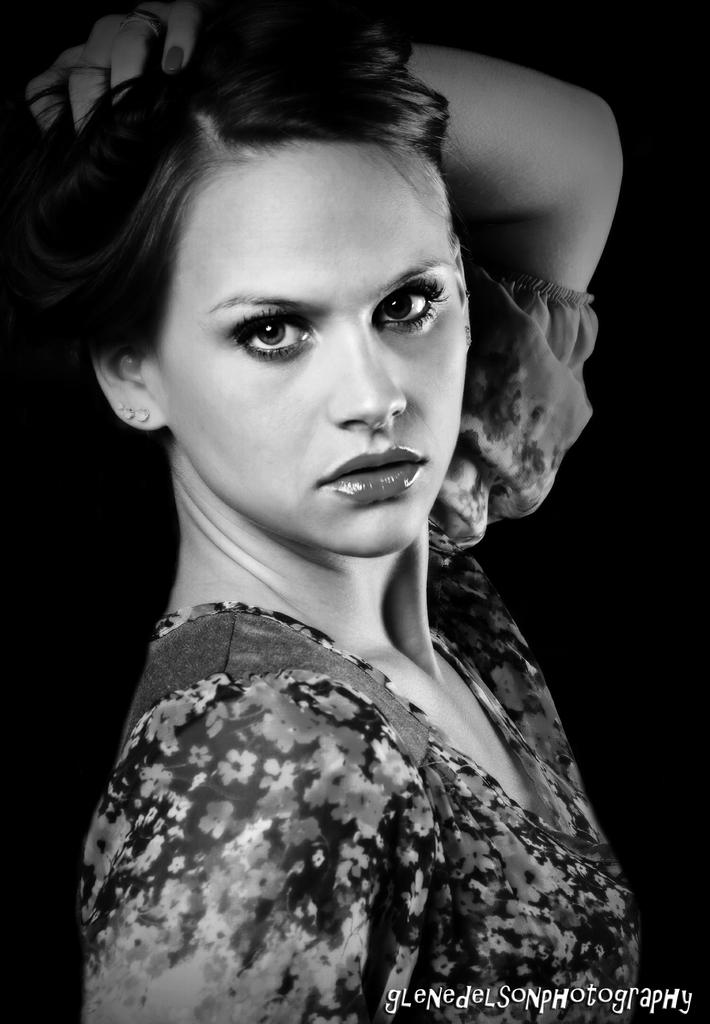What is the color scheme of the image? The image is black and white. Who is present in the image? There is a woman in the image. What is the woman doing in the image? The woman is posing to the camera. What can be seen in the background of the image? The background of the image is dark. Can you see any basketball players stuck in quicksand in the image? There are no basketball players or quicksand present in the image; it features a woman posing in a dark background. What type of vegetable is being used as a prop in the image? There is no vegetable present in the image. 